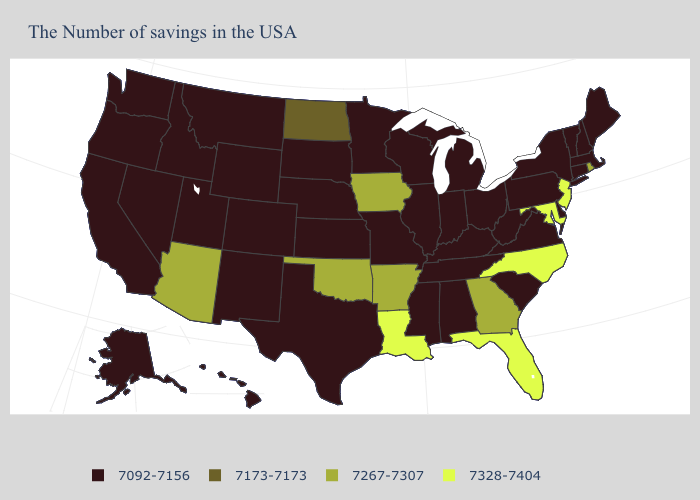What is the value of South Carolina?
Quick response, please. 7092-7156. What is the value of South Dakota?
Write a very short answer. 7092-7156. What is the lowest value in the USA?
Write a very short answer. 7092-7156. Among the states that border Kansas , which have the highest value?
Quick response, please. Oklahoma. What is the value of Nevada?
Keep it brief. 7092-7156. What is the value of New Jersey?
Keep it brief. 7328-7404. What is the value of Ohio?
Concise answer only. 7092-7156. Does Illinois have the lowest value in the USA?
Keep it brief. Yes. Does Arizona have the highest value in the West?
Keep it brief. Yes. Name the states that have a value in the range 7092-7156?
Keep it brief. Maine, Massachusetts, New Hampshire, Vermont, Connecticut, New York, Delaware, Pennsylvania, Virginia, South Carolina, West Virginia, Ohio, Michigan, Kentucky, Indiana, Alabama, Tennessee, Wisconsin, Illinois, Mississippi, Missouri, Minnesota, Kansas, Nebraska, Texas, South Dakota, Wyoming, Colorado, New Mexico, Utah, Montana, Idaho, Nevada, California, Washington, Oregon, Alaska, Hawaii. What is the value of Kansas?
Quick response, please. 7092-7156. Does the map have missing data?
Be succinct. No. What is the value of North Dakota?
Be succinct. 7173-7173. What is the highest value in states that border West Virginia?
Answer briefly. 7328-7404. What is the value of Kansas?
Keep it brief. 7092-7156. 